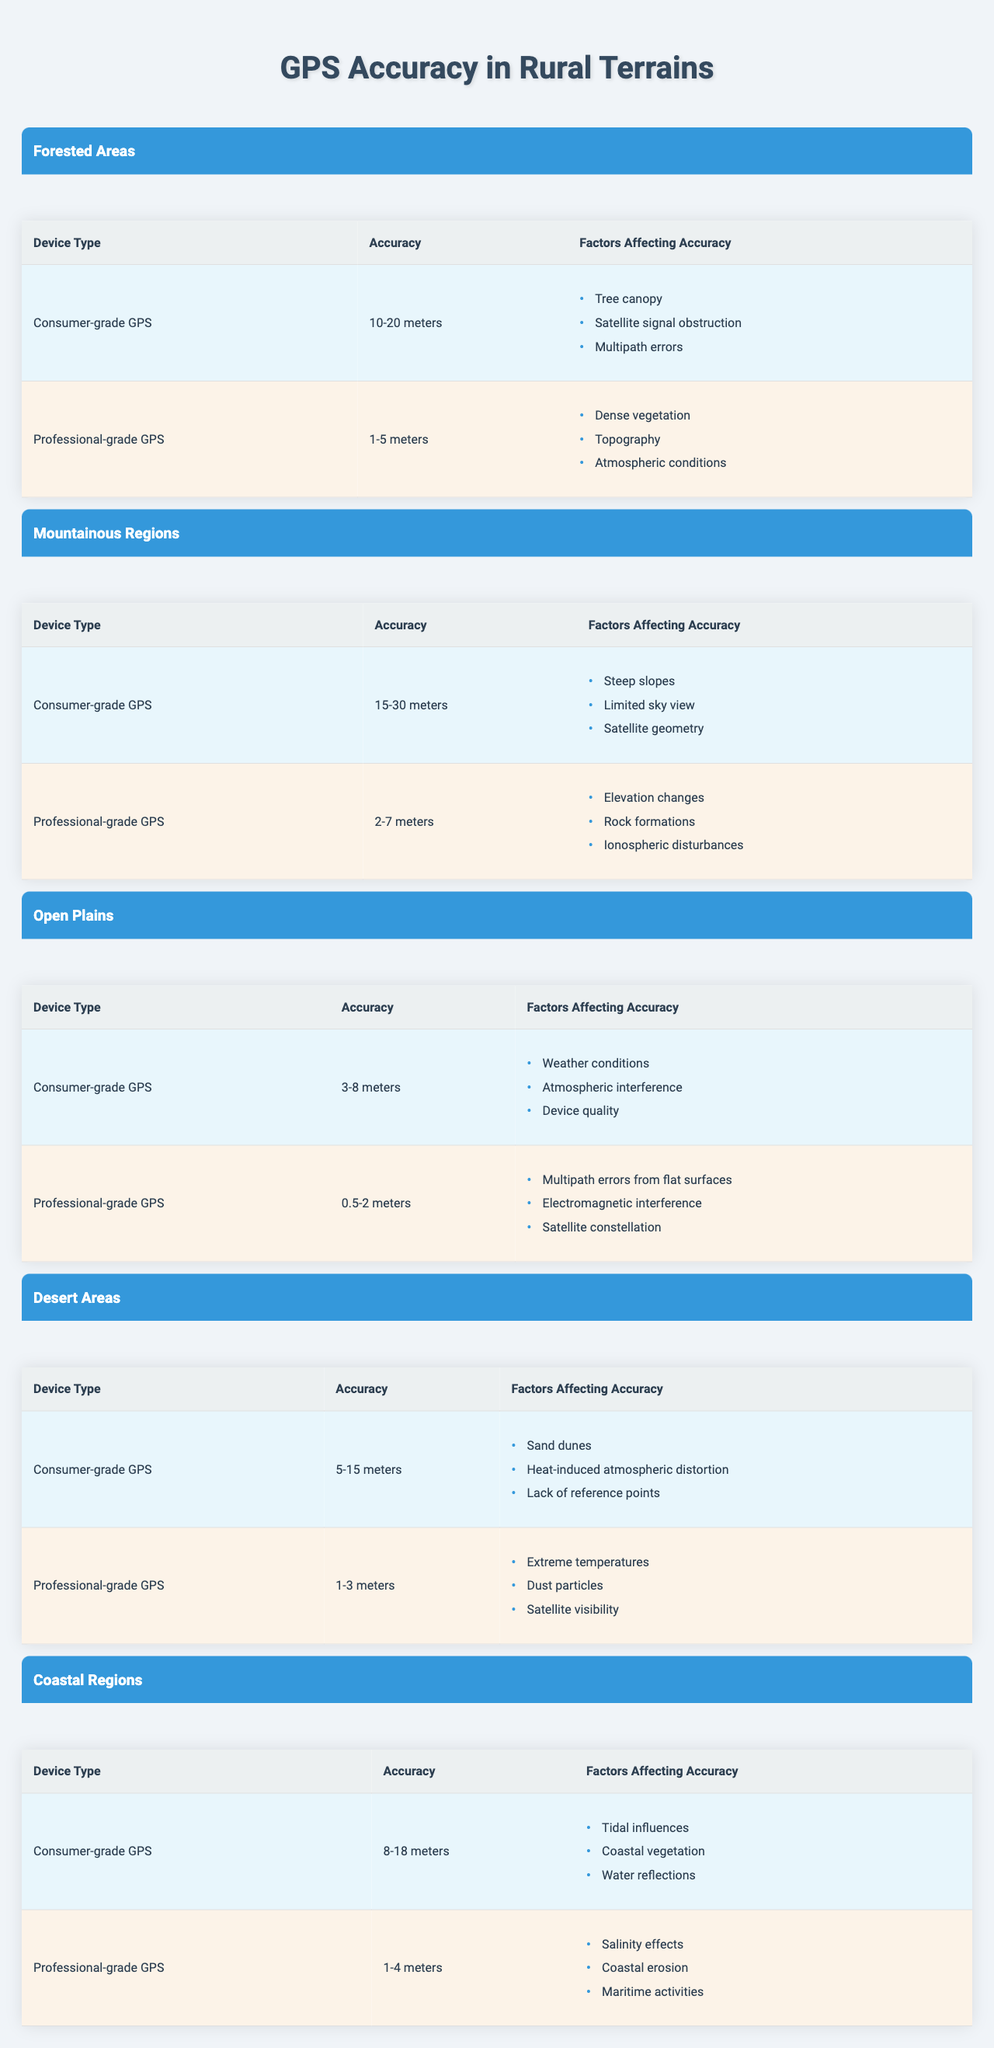What is the accuracy level of consumer-grade GPS in forested areas? The table indicates that the accuracy level for consumer-grade GPS in forested areas is between 10-20 meters.
Answer: 10-20 meters Which GPS device type has the best accuracy in coastal regions? According to the table, professional-grade GPS has the best accuracy in coastal regions, with an accuracy of 1-4 meters.
Answer: Professional-grade GPS What factors affect the accuracy of consumer-grade GPS in desert areas? The table lists the factors affecting the accuracy of consumer-grade GPS in desert areas as sand dunes, heat-induced atmospheric distortion, and lack of reference points.
Answer: Sand dunes, heat-induced atmospheric distortion, lack of reference points How does the accuracy of professional-grade GPS in mountainous regions compare to that in forested areas? The accuracy of professional-grade GPS in mountainous regions ranges from 2-7 meters, while in forested areas it is 1-5 meters. The accuracy in mountainous regions is generally higher.
Answer: Higher in mountainous regions What is the average accuracy of consumer-grade GPS across all terrain types? The accuracy levels for consumer-grade GPS are: 10-20m (Forested), 15-30m (Mountainous), 3-8m (Open Plains), 5-15m (Desert), and 8-18m (Coastal). To find the average, we first determine the midpoints: 15m, 22.5m, 5.5m, 10m, and 13m respectively. Adding these gives 75m and dividing by 5 gives an average of 15m.
Answer: 15 meters Is professional-grade GPS more accurate than consumer-grade GPS in rural terrains? Yes, the table shows that in every terrain type listed, professional-grade GPS consistently has better accuracy than consumer-grade GPS.
Answer: Yes What factors commonly affect professional-grade GPS accuracy in both desert and coastal regions? The table indicates that factors affecting professional-grade GPS accuracy in both desert and coastal regions include satellite visibility (desert) and salinity effects (coastal), but there isn’t a direct common factor.
Answer: No common factor What terrain type has the widest range of accuracy for consumer-grade GPS? The table shows that mountainous regions have the widest range of accuracy for consumer-grade GPS, between 15-30 meters.
Answer: Mountainous Regions Which terrain has the least variability in professional-grade GPS accuracy? Upon reviewing the accuracy levels, open plains display the least variability with a range of 0.5-2 meters, compared to other terrains which have greater ranges.
Answer: Open Plains 